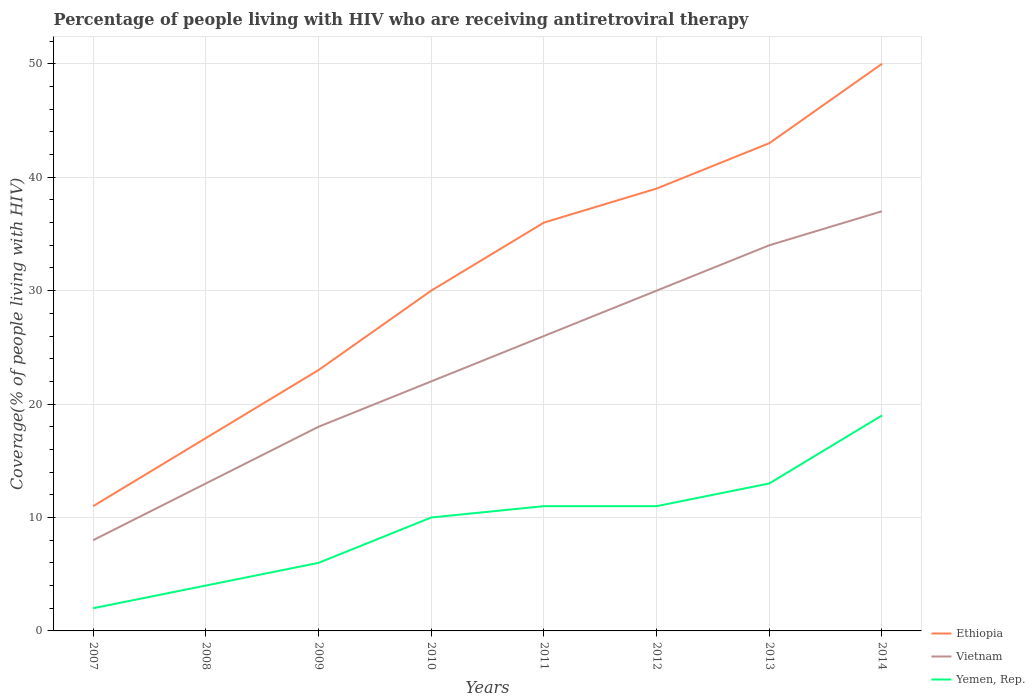Across all years, what is the maximum percentage of the HIV infected people who are receiving antiretroviral therapy in Vietnam?
Your answer should be very brief. 8. What is the total percentage of the HIV infected people who are receiving antiretroviral therapy in Yemen, Rep. in the graph?
Make the answer very short. -9. What is the difference between the highest and the second highest percentage of the HIV infected people who are receiving antiretroviral therapy in Ethiopia?
Give a very brief answer. 39. Is the percentage of the HIV infected people who are receiving antiretroviral therapy in Vietnam strictly greater than the percentage of the HIV infected people who are receiving antiretroviral therapy in Ethiopia over the years?
Your response must be concise. Yes. How many lines are there?
Provide a succinct answer. 3. What is the difference between two consecutive major ticks on the Y-axis?
Keep it short and to the point. 10. Where does the legend appear in the graph?
Make the answer very short. Bottom right. How many legend labels are there?
Give a very brief answer. 3. What is the title of the graph?
Provide a short and direct response. Percentage of people living with HIV who are receiving antiretroviral therapy. What is the label or title of the Y-axis?
Offer a terse response. Coverage(% of people living with HIV). What is the Coverage(% of people living with HIV) in Ethiopia in 2007?
Provide a succinct answer. 11. What is the Coverage(% of people living with HIV) of Yemen, Rep. in 2007?
Your answer should be very brief. 2. What is the Coverage(% of people living with HIV) in Ethiopia in 2008?
Give a very brief answer. 17. What is the Coverage(% of people living with HIV) in Yemen, Rep. in 2008?
Keep it short and to the point. 4. What is the Coverage(% of people living with HIV) in Ethiopia in 2009?
Offer a very short reply. 23. What is the Coverage(% of people living with HIV) in Yemen, Rep. in 2009?
Ensure brevity in your answer.  6. What is the Coverage(% of people living with HIV) of Ethiopia in 2011?
Offer a terse response. 36. What is the Coverage(% of people living with HIV) in Vietnam in 2011?
Provide a succinct answer. 26. What is the Coverage(% of people living with HIV) in Yemen, Rep. in 2013?
Your response must be concise. 13. What is the Coverage(% of people living with HIV) in Vietnam in 2014?
Offer a terse response. 37. Across all years, what is the maximum Coverage(% of people living with HIV) of Ethiopia?
Your answer should be very brief. 50. Across all years, what is the minimum Coverage(% of people living with HIV) of Yemen, Rep.?
Keep it short and to the point. 2. What is the total Coverage(% of people living with HIV) of Ethiopia in the graph?
Give a very brief answer. 249. What is the total Coverage(% of people living with HIV) of Vietnam in the graph?
Your response must be concise. 188. What is the difference between the Coverage(% of people living with HIV) of Ethiopia in 2007 and that in 2008?
Provide a succinct answer. -6. What is the difference between the Coverage(% of people living with HIV) in Vietnam in 2007 and that in 2008?
Your answer should be very brief. -5. What is the difference between the Coverage(% of people living with HIV) of Yemen, Rep. in 2007 and that in 2008?
Keep it short and to the point. -2. What is the difference between the Coverage(% of people living with HIV) in Vietnam in 2007 and that in 2009?
Provide a succinct answer. -10. What is the difference between the Coverage(% of people living with HIV) of Yemen, Rep. in 2007 and that in 2009?
Make the answer very short. -4. What is the difference between the Coverage(% of people living with HIV) in Ethiopia in 2007 and that in 2010?
Offer a very short reply. -19. What is the difference between the Coverage(% of people living with HIV) in Vietnam in 2007 and that in 2011?
Your answer should be compact. -18. What is the difference between the Coverage(% of people living with HIV) of Ethiopia in 2007 and that in 2012?
Provide a short and direct response. -28. What is the difference between the Coverage(% of people living with HIV) of Vietnam in 2007 and that in 2012?
Your response must be concise. -22. What is the difference between the Coverage(% of people living with HIV) of Yemen, Rep. in 2007 and that in 2012?
Offer a terse response. -9. What is the difference between the Coverage(% of people living with HIV) of Ethiopia in 2007 and that in 2013?
Give a very brief answer. -32. What is the difference between the Coverage(% of people living with HIV) in Vietnam in 2007 and that in 2013?
Your response must be concise. -26. What is the difference between the Coverage(% of people living with HIV) of Ethiopia in 2007 and that in 2014?
Give a very brief answer. -39. What is the difference between the Coverage(% of people living with HIV) of Ethiopia in 2008 and that in 2009?
Your answer should be very brief. -6. What is the difference between the Coverage(% of people living with HIV) in Vietnam in 2008 and that in 2009?
Keep it short and to the point. -5. What is the difference between the Coverage(% of people living with HIV) of Yemen, Rep. in 2008 and that in 2009?
Make the answer very short. -2. What is the difference between the Coverage(% of people living with HIV) in Ethiopia in 2008 and that in 2010?
Give a very brief answer. -13. What is the difference between the Coverage(% of people living with HIV) in Vietnam in 2008 and that in 2010?
Keep it short and to the point. -9. What is the difference between the Coverage(% of people living with HIV) of Yemen, Rep. in 2008 and that in 2010?
Offer a very short reply. -6. What is the difference between the Coverage(% of people living with HIV) of Ethiopia in 2008 and that in 2011?
Provide a short and direct response. -19. What is the difference between the Coverage(% of people living with HIV) in Vietnam in 2008 and that in 2011?
Offer a very short reply. -13. What is the difference between the Coverage(% of people living with HIV) of Yemen, Rep. in 2008 and that in 2011?
Your answer should be very brief. -7. What is the difference between the Coverage(% of people living with HIV) in Ethiopia in 2008 and that in 2012?
Give a very brief answer. -22. What is the difference between the Coverage(% of people living with HIV) of Vietnam in 2008 and that in 2012?
Your response must be concise. -17. What is the difference between the Coverage(% of people living with HIV) in Yemen, Rep. in 2008 and that in 2013?
Your answer should be compact. -9. What is the difference between the Coverage(% of people living with HIV) in Ethiopia in 2008 and that in 2014?
Give a very brief answer. -33. What is the difference between the Coverage(% of people living with HIV) of Yemen, Rep. in 2008 and that in 2014?
Offer a very short reply. -15. What is the difference between the Coverage(% of people living with HIV) in Ethiopia in 2009 and that in 2010?
Provide a short and direct response. -7. What is the difference between the Coverage(% of people living with HIV) of Vietnam in 2009 and that in 2010?
Ensure brevity in your answer.  -4. What is the difference between the Coverage(% of people living with HIV) in Vietnam in 2009 and that in 2011?
Provide a short and direct response. -8. What is the difference between the Coverage(% of people living with HIV) in Ethiopia in 2009 and that in 2012?
Keep it short and to the point. -16. What is the difference between the Coverage(% of people living with HIV) of Vietnam in 2009 and that in 2012?
Offer a very short reply. -12. What is the difference between the Coverage(% of people living with HIV) in Ethiopia in 2009 and that in 2013?
Your answer should be compact. -20. What is the difference between the Coverage(% of people living with HIV) in Vietnam in 2009 and that in 2014?
Provide a short and direct response. -19. What is the difference between the Coverage(% of people living with HIV) in Yemen, Rep. in 2009 and that in 2014?
Make the answer very short. -13. What is the difference between the Coverage(% of people living with HIV) in Ethiopia in 2010 and that in 2012?
Your response must be concise. -9. What is the difference between the Coverage(% of people living with HIV) of Yemen, Rep. in 2010 and that in 2012?
Make the answer very short. -1. What is the difference between the Coverage(% of people living with HIV) in Vietnam in 2010 and that in 2013?
Offer a very short reply. -12. What is the difference between the Coverage(% of people living with HIV) in Yemen, Rep. in 2010 and that in 2013?
Offer a terse response. -3. What is the difference between the Coverage(% of people living with HIV) in Vietnam in 2011 and that in 2012?
Keep it short and to the point. -4. What is the difference between the Coverage(% of people living with HIV) of Vietnam in 2011 and that in 2013?
Keep it short and to the point. -8. What is the difference between the Coverage(% of people living with HIV) in Yemen, Rep. in 2011 and that in 2013?
Your response must be concise. -2. What is the difference between the Coverage(% of people living with HIV) in Ethiopia in 2011 and that in 2014?
Ensure brevity in your answer.  -14. What is the difference between the Coverage(% of people living with HIV) in Yemen, Rep. in 2011 and that in 2014?
Give a very brief answer. -8. What is the difference between the Coverage(% of people living with HIV) in Vietnam in 2012 and that in 2013?
Give a very brief answer. -4. What is the difference between the Coverage(% of people living with HIV) in Vietnam in 2012 and that in 2014?
Offer a terse response. -7. What is the difference between the Coverage(% of people living with HIV) of Yemen, Rep. in 2012 and that in 2014?
Provide a succinct answer. -8. What is the difference between the Coverage(% of people living with HIV) in Vietnam in 2013 and that in 2014?
Ensure brevity in your answer.  -3. What is the difference between the Coverage(% of people living with HIV) in Ethiopia in 2007 and the Coverage(% of people living with HIV) in Vietnam in 2008?
Give a very brief answer. -2. What is the difference between the Coverage(% of people living with HIV) of Vietnam in 2007 and the Coverage(% of people living with HIV) of Yemen, Rep. in 2008?
Your answer should be compact. 4. What is the difference between the Coverage(% of people living with HIV) of Ethiopia in 2007 and the Coverage(% of people living with HIV) of Vietnam in 2009?
Offer a terse response. -7. What is the difference between the Coverage(% of people living with HIV) of Ethiopia in 2007 and the Coverage(% of people living with HIV) of Yemen, Rep. in 2009?
Provide a succinct answer. 5. What is the difference between the Coverage(% of people living with HIV) in Ethiopia in 2007 and the Coverage(% of people living with HIV) in Vietnam in 2010?
Your answer should be compact. -11. What is the difference between the Coverage(% of people living with HIV) of Ethiopia in 2007 and the Coverage(% of people living with HIV) of Yemen, Rep. in 2010?
Keep it short and to the point. 1. What is the difference between the Coverage(% of people living with HIV) of Vietnam in 2007 and the Coverage(% of people living with HIV) of Yemen, Rep. in 2010?
Give a very brief answer. -2. What is the difference between the Coverage(% of people living with HIV) of Vietnam in 2007 and the Coverage(% of people living with HIV) of Yemen, Rep. in 2011?
Give a very brief answer. -3. What is the difference between the Coverage(% of people living with HIV) in Ethiopia in 2007 and the Coverage(% of people living with HIV) in Vietnam in 2012?
Provide a short and direct response. -19. What is the difference between the Coverage(% of people living with HIV) in Vietnam in 2007 and the Coverage(% of people living with HIV) in Yemen, Rep. in 2013?
Your answer should be compact. -5. What is the difference between the Coverage(% of people living with HIV) in Ethiopia in 2007 and the Coverage(% of people living with HIV) in Vietnam in 2014?
Give a very brief answer. -26. What is the difference between the Coverage(% of people living with HIV) in Ethiopia in 2008 and the Coverage(% of people living with HIV) in Vietnam in 2009?
Your answer should be very brief. -1. What is the difference between the Coverage(% of people living with HIV) in Vietnam in 2008 and the Coverage(% of people living with HIV) in Yemen, Rep. in 2009?
Provide a succinct answer. 7. What is the difference between the Coverage(% of people living with HIV) in Ethiopia in 2008 and the Coverage(% of people living with HIV) in Vietnam in 2011?
Give a very brief answer. -9. What is the difference between the Coverage(% of people living with HIV) in Ethiopia in 2008 and the Coverage(% of people living with HIV) in Yemen, Rep. in 2011?
Ensure brevity in your answer.  6. What is the difference between the Coverage(% of people living with HIV) of Ethiopia in 2008 and the Coverage(% of people living with HIV) of Yemen, Rep. in 2012?
Provide a short and direct response. 6. What is the difference between the Coverage(% of people living with HIV) in Vietnam in 2008 and the Coverage(% of people living with HIV) in Yemen, Rep. in 2013?
Provide a succinct answer. 0. What is the difference between the Coverage(% of people living with HIV) in Ethiopia in 2008 and the Coverage(% of people living with HIV) in Vietnam in 2014?
Ensure brevity in your answer.  -20. What is the difference between the Coverage(% of people living with HIV) in Ethiopia in 2009 and the Coverage(% of people living with HIV) in Yemen, Rep. in 2011?
Your response must be concise. 12. What is the difference between the Coverage(% of people living with HIV) of Vietnam in 2009 and the Coverage(% of people living with HIV) of Yemen, Rep. in 2011?
Offer a terse response. 7. What is the difference between the Coverage(% of people living with HIV) in Ethiopia in 2009 and the Coverage(% of people living with HIV) in Vietnam in 2013?
Provide a short and direct response. -11. What is the difference between the Coverage(% of people living with HIV) in Ethiopia in 2009 and the Coverage(% of people living with HIV) in Yemen, Rep. in 2013?
Ensure brevity in your answer.  10. What is the difference between the Coverage(% of people living with HIV) of Vietnam in 2009 and the Coverage(% of people living with HIV) of Yemen, Rep. in 2013?
Offer a very short reply. 5. What is the difference between the Coverage(% of people living with HIV) of Vietnam in 2009 and the Coverage(% of people living with HIV) of Yemen, Rep. in 2014?
Your answer should be very brief. -1. What is the difference between the Coverage(% of people living with HIV) in Ethiopia in 2010 and the Coverage(% of people living with HIV) in Vietnam in 2011?
Provide a short and direct response. 4. What is the difference between the Coverage(% of people living with HIV) in Ethiopia in 2010 and the Coverage(% of people living with HIV) in Vietnam in 2012?
Ensure brevity in your answer.  0. What is the difference between the Coverage(% of people living with HIV) in Vietnam in 2010 and the Coverage(% of people living with HIV) in Yemen, Rep. in 2012?
Offer a terse response. 11. What is the difference between the Coverage(% of people living with HIV) of Ethiopia in 2010 and the Coverage(% of people living with HIV) of Yemen, Rep. in 2013?
Offer a very short reply. 17. What is the difference between the Coverage(% of people living with HIV) in Vietnam in 2010 and the Coverage(% of people living with HIV) in Yemen, Rep. in 2014?
Your response must be concise. 3. What is the difference between the Coverage(% of people living with HIV) in Ethiopia in 2011 and the Coverage(% of people living with HIV) in Yemen, Rep. in 2012?
Provide a succinct answer. 25. What is the difference between the Coverage(% of people living with HIV) of Vietnam in 2011 and the Coverage(% of people living with HIV) of Yemen, Rep. in 2012?
Offer a terse response. 15. What is the difference between the Coverage(% of people living with HIV) in Ethiopia in 2011 and the Coverage(% of people living with HIV) in Vietnam in 2013?
Provide a short and direct response. 2. What is the difference between the Coverage(% of people living with HIV) of Ethiopia in 2011 and the Coverage(% of people living with HIV) of Yemen, Rep. in 2013?
Make the answer very short. 23. What is the difference between the Coverage(% of people living with HIV) of Vietnam in 2011 and the Coverage(% of people living with HIV) of Yemen, Rep. in 2013?
Give a very brief answer. 13. What is the difference between the Coverage(% of people living with HIV) of Vietnam in 2011 and the Coverage(% of people living with HIV) of Yemen, Rep. in 2014?
Ensure brevity in your answer.  7. What is the difference between the Coverage(% of people living with HIV) in Ethiopia in 2012 and the Coverage(% of people living with HIV) in Vietnam in 2013?
Provide a short and direct response. 5. What is the difference between the Coverage(% of people living with HIV) of Ethiopia in 2012 and the Coverage(% of people living with HIV) of Vietnam in 2014?
Offer a terse response. 2. What is the average Coverage(% of people living with HIV) of Ethiopia per year?
Make the answer very short. 31.12. What is the average Coverage(% of people living with HIV) in Yemen, Rep. per year?
Provide a succinct answer. 9.5. In the year 2007, what is the difference between the Coverage(% of people living with HIV) of Ethiopia and Coverage(% of people living with HIV) of Vietnam?
Offer a terse response. 3. In the year 2007, what is the difference between the Coverage(% of people living with HIV) of Ethiopia and Coverage(% of people living with HIV) of Yemen, Rep.?
Offer a very short reply. 9. In the year 2008, what is the difference between the Coverage(% of people living with HIV) in Vietnam and Coverage(% of people living with HIV) in Yemen, Rep.?
Offer a terse response. 9. In the year 2009, what is the difference between the Coverage(% of people living with HIV) in Ethiopia and Coverage(% of people living with HIV) in Vietnam?
Your answer should be very brief. 5. In the year 2009, what is the difference between the Coverage(% of people living with HIV) of Vietnam and Coverage(% of people living with HIV) of Yemen, Rep.?
Your response must be concise. 12. In the year 2010, what is the difference between the Coverage(% of people living with HIV) of Ethiopia and Coverage(% of people living with HIV) of Vietnam?
Your answer should be very brief. 8. In the year 2010, what is the difference between the Coverage(% of people living with HIV) of Vietnam and Coverage(% of people living with HIV) of Yemen, Rep.?
Make the answer very short. 12. In the year 2011, what is the difference between the Coverage(% of people living with HIV) of Vietnam and Coverage(% of people living with HIV) of Yemen, Rep.?
Keep it short and to the point. 15. In the year 2012, what is the difference between the Coverage(% of people living with HIV) in Ethiopia and Coverage(% of people living with HIV) in Vietnam?
Provide a short and direct response. 9. In the year 2012, what is the difference between the Coverage(% of people living with HIV) in Ethiopia and Coverage(% of people living with HIV) in Yemen, Rep.?
Give a very brief answer. 28. In the year 2013, what is the difference between the Coverage(% of people living with HIV) of Ethiopia and Coverage(% of people living with HIV) of Vietnam?
Offer a terse response. 9. In the year 2013, what is the difference between the Coverage(% of people living with HIV) of Ethiopia and Coverage(% of people living with HIV) of Yemen, Rep.?
Offer a very short reply. 30. In the year 2013, what is the difference between the Coverage(% of people living with HIV) of Vietnam and Coverage(% of people living with HIV) of Yemen, Rep.?
Provide a short and direct response. 21. What is the ratio of the Coverage(% of people living with HIV) of Ethiopia in 2007 to that in 2008?
Your answer should be very brief. 0.65. What is the ratio of the Coverage(% of people living with HIV) of Vietnam in 2007 to that in 2008?
Make the answer very short. 0.62. What is the ratio of the Coverage(% of people living with HIV) in Yemen, Rep. in 2007 to that in 2008?
Your answer should be compact. 0.5. What is the ratio of the Coverage(% of people living with HIV) in Ethiopia in 2007 to that in 2009?
Your response must be concise. 0.48. What is the ratio of the Coverage(% of people living with HIV) in Vietnam in 2007 to that in 2009?
Keep it short and to the point. 0.44. What is the ratio of the Coverage(% of people living with HIV) of Yemen, Rep. in 2007 to that in 2009?
Your answer should be very brief. 0.33. What is the ratio of the Coverage(% of people living with HIV) of Ethiopia in 2007 to that in 2010?
Your answer should be compact. 0.37. What is the ratio of the Coverage(% of people living with HIV) in Vietnam in 2007 to that in 2010?
Give a very brief answer. 0.36. What is the ratio of the Coverage(% of people living with HIV) in Ethiopia in 2007 to that in 2011?
Provide a succinct answer. 0.31. What is the ratio of the Coverage(% of people living with HIV) of Vietnam in 2007 to that in 2011?
Ensure brevity in your answer.  0.31. What is the ratio of the Coverage(% of people living with HIV) of Yemen, Rep. in 2007 to that in 2011?
Keep it short and to the point. 0.18. What is the ratio of the Coverage(% of people living with HIV) in Ethiopia in 2007 to that in 2012?
Keep it short and to the point. 0.28. What is the ratio of the Coverage(% of people living with HIV) in Vietnam in 2007 to that in 2012?
Offer a very short reply. 0.27. What is the ratio of the Coverage(% of people living with HIV) in Yemen, Rep. in 2007 to that in 2012?
Ensure brevity in your answer.  0.18. What is the ratio of the Coverage(% of people living with HIV) in Ethiopia in 2007 to that in 2013?
Your answer should be compact. 0.26. What is the ratio of the Coverage(% of people living with HIV) of Vietnam in 2007 to that in 2013?
Make the answer very short. 0.24. What is the ratio of the Coverage(% of people living with HIV) of Yemen, Rep. in 2007 to that in 2013?
Make the answer very short. 0.15. What is the ratio of the Coverage(% of people living with HIV) in Ethiopia in 2007 to that in 2014?
Give a very brief answer. 0.22. What is the ratio of the Coverage(% of people living with HIV) of Vietnam in 2007 to that in 2014?
Provide a succinct answer. 0.22. What is the ratio of the Coverage(% of people living with HIV) in Yemen, Rep. in 2007 to that in 2014?
Offer a terse response. 0.11. What is the ratio of the Coverage(% of people living with HIV) of Ethiopia in 2008 to that in 2009?
Make the answer very short. 0.74. What is the ratio of the Coverage(% of people living with HIV) in Vietnam in 2008 to that in 2009?
Provide a succinct answer. 0.72. What is the ratio of the Coverage(% of people living with HIV) in Yemen, Rep. in 2008 to that in 2009?
Keep it short and to the point. 0.67. What is the ratio of the Coverage(% of people living with HIV) of Ethiopia in 2008 to that in 2010?
Offer a very short reply. 0.57. What is the ratio of the Coverage(% of people living with HIV) of Vietnam in 2008 to that in 2010?
Give a very brief answer. 0.59. What is the ratio of the Coverage(% of people living with HIV) of Ethiopia in 2008 to that in 2011?
Ensure brevity in your answer.  0.47. What is the ratio of the Coverage(% of people living with HIV) in Vietnam in 2008 to that in 2011?
Your answer should be very brief. 0.5. What is the ratio of the Coverage(% of people living with HIV) of Yemen, Rep. in 2008 to that in 2011?
Ensure brevity in your answer.  0.36. What is the ratio of the Coverage(% of people living with HIV) in Ethiopia in 2008 to that in 2012?
Keep it short and to the point. 0.44. What is the ratio of the Coverage(% of people living with HIV) in Vietnam in 2008 to that in 2012?
Your answer should be compact. 0.43. What is the ratio of the Coverage(% of people living with HIV) in Yemen, Rep. in 2008 to that in 2012?
Provide a short and direct response. 0.36. What is the ratio of the Coverage(% of people living with HIV) in Ethiopia in 2008 to that in 2013?
Ensure brevity in your answer.  0.4. What is the ratio of the Coverage(% of people living with HIV) in Vietnam in 2008 to that in 2013?
Offer a very short reply. 0.38. What is the ratio of the Coverage(% of people living with HIV) in Yemen, Rep. in 2008 to that in 2013?
Ensure brevity in your answer.  0.31. What is the ratio of the Coverage(% of people living with HIV) of Ethiopia in 2008 to that in 2014?
Offer a terse response. 0.34. What is the ratio of the Coverage(% of people living with HIV) in Vietnam in 2008 to that in 2014?
Your response must be concise. 0.35. What is the ratio of the Coverage(% of people living with HIV) in Yemen, Rep. in 2008 to that in 2014?
Ensure brevity in your answer.  0.21. What is the ratio of the Coverage(% of people living with HIV) of Ethiopia in 2009 to that in 2010?
Keep it short and to the point. 0.77. What is the ratio of the Coverage(% of people living with HIV) in Vietnam in 2009 to that in 2010?
Offer a terse response. 0.82. What is the ratio of the Coverage(% of people living with HIV) of Yemen, Rep. in 2009 to that in 2010?
Offer a very short reply. 0.6. What is the ratio of the Coverage(% of people living with HIV) in Ethiopia in 2009 to that in 2011?
Provide a succinct answer. 0.64. What is the ratio of the Coverage(% of people living with HIV) in Vietnam in 2009 to that in 2011?
Offer a very short reply. 0.69. What is the ratio of the Coverage(% of people living with HIV) in Yemen, Rep. in 2009 to that in 2011?
Give a very brief answer. 0.55. What is the ratio of the Coverage(% of people living with HIV) in Ethiopia in 2009 to that in 2012?
Ensure brevity in your answer.  0.59. What is the ratio of the Coverage(% of people living with HIV) in Vietnam in 2009 to that in 2012?
Your response must be concise. 0.6. What is the ratio of the Coverage(% of people living with HIV) in Yemen, Rep. in 2009 to that in 2012?
Make the answer very short. 0.55. What is the ratio of the Coverage(% of people living with HIV) of Ethiopia in 2009 to that in 2013?
Offer a very short reply. 0.53. What is the ratio of the Coverage(% of people living with HIV) in Vietnam in 2009 to that in 2013?
Ensure brevity in your answer.  0.53. What is the ratio of the Coverage(% of people living with HIV) of Yemen, Rep. in 2009 to that in 2013?
Give a very brief answer. 0.46. What is the ratio of the Coverage(% of people living with HIV) of Ethiopia in 2009 to that in 2014?
Keep it short and to the point. 0.46. What is the ratio of the Coverage(% of people living with HIV) of Vietnam in 2009 to that in 2014?
Provide a short and direct response. 0.49. What is the ratio of the Coverage(% of people living with HIV) in Yemen, Rep. in 2009 to that in 2014?
Offer a terse response. 0.32. What is the ratio of the Coverage(% of people living with HIV) of Ethiopia in 2010 to that in 2011?
Ensure brevity in your answer.  0.83. What is the ratio of the Coverage(% of people living with HIV) in Vietnam in 2010 to that in 2011?
Keep it short and to the point. 0.85. What is the ratio of the Coverage(% of people living with HIV) in Yemen, Rep. in 2010 to that in 2011?
Your response must be concise. 0.91. What is the ratio of the Coverage(% of people living with HIV) of Ethiopia in 2010 to that in 2012?
Provide a succinct answer. 0.77. What is the ratio of the Coverage(% of people living with HIV) of Vietnam in 2010 to that in 2012?
Keep it short and to the point. 0.73. What is the ratio of the Coverage(% of people living with HIV) in Yemen, Rep. in 2010 to that in 2012?
Ensure brevity in your answer.  0.91. What is the ratio of the Coverage(% of people living with HIV) of Ethiopia in 2010 to that in 2013?
Your answer should be very brief. 0.7. What is the ratio of the Coverage(% of people living with HIV) of Vietnam in 2010 to that in 2013?
Keep it short and to the point. 0.65. What is the ratio of the Coverage(% of people living with HIV) in Yemen, Rep. in 2010 to that in 2013?
Offer a very short reply. 0.77. What is the ratio of the Coverage(% of people living with HIV) in Vietnam in 2010 to that in 2014?
Ensure brevity in your answer.  0.59. What is the ratio of the Coverage(% of people living with HIV) of Yemen, Rep. in 2010 to that in 2014?
Offer a terse response. 0.53. What is the ratio of the Coverage(% of people living with HIV) of Vietnam in 2011 to that in 2012?
Ensure brevity in your answer.  0.87. What is the ratio of the Coverage(% of people living with HIV) in Yemen, Rep. in 2011 to that in 2012?
Your answer should be very brief. 1. What is the ratio of the Coverage(% of people living with HIV) of Ethiopia in 2011 to that in 2013?
Provide a short and direct response. 0.84. What is the ratio of the Coverage(% of people living with HIV) of Vietnam in 2011 to that in 2013?
Offer a very short reply. 0.76. What is the ratio of the Coverage(% of people living with HIV) in Yemen, Rep. in 2011 to that in 2013?
Give a very brief answer. 0.85. What is the ratio of the Coverage(% of people living with HIV) in Ethiopia in 2011 to that in 2014?
Keep it short and to the point. 0.72. What is the ratio of the Coverage(% of people living with HIV) of Vietnam in 2011 to that in 2014?
Offer a terse response. 0.7. What is the ratio of the Coverage(% of people living with HIV) in Yemen, Rep. in 2011 to that in 2014?
Offer a very short reply. 0.58. What is the ratio of the Coverage(% of people living with HIV) of Ethiopia in 2012 to that in 2013?
Give a very brief answer. 0.91. What is the ratio of the Coverage(% of people living with HIV) of Vietnam in 2012 to that in 2013?
Make the answer very short. 0.88. What is the ratio of the Coverage(% of people living with HIV) of Yemen, Rep. in 2012 to that in 2013?
Provide a succinct answer. 0.85. What is the ratio of the Coverage(% of people living with HIV) of Ethiopia in 2012 to that in 2014?
Your response must be concise. 0.78. What is the ratio of the Coverage(% of people living with HIV) in Vietnam in 2012 to that in 2014?
Give a very brief answer. 0.81. What is the ratio of the Coverage(% of people living with HIV) in Yemen, Rep. in 2012 to that in 2014?
Your response must be concise. 0.58. What is the ratio of the Coverage(% of people living with HIV) of Ethiopia in 2013 to that in 2014?
Your answer should be compact. 0.86. What is the ratio of the Coverage(% of people living with HIV) in Vietnam in 2013 to that in 2014?
Give a very brief answer. 0.92. What is the ratio of the Coverage(% of people living with HIV) of Yemen, Rep. in 2013 to that in 2014?
Provide a short and direct response. 0.68. What is the difference between the highest and the second highest Coverage(% of people living with HIV) of Ethiopia?
Provide a short and direct response. 7. What is the difference between the highest and the second highest Coverage(% of people living with HIV) in Vietnam?
Provide a short and direct response. 3. What is the difference between the highest and the second highest Coverage(% of people living with HIV) in Yemen, Rep.?
Make the answer very short. 6. 